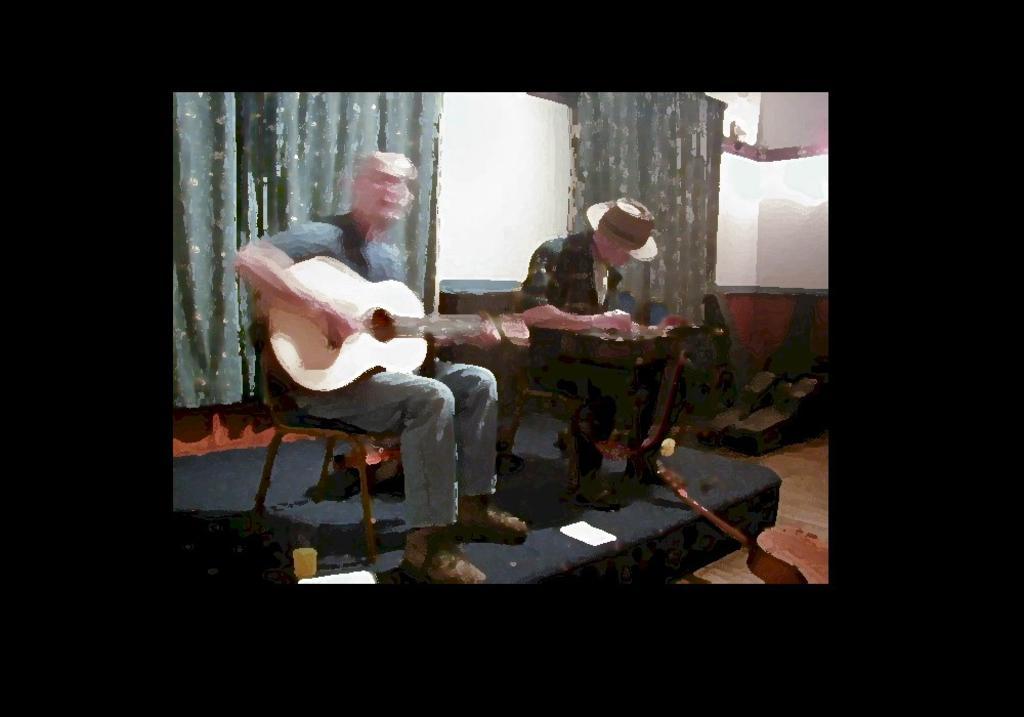Describe this image in one or two sentences. In this image i can see two person sitting and playing guitar at the back ground i can see a curtain. 